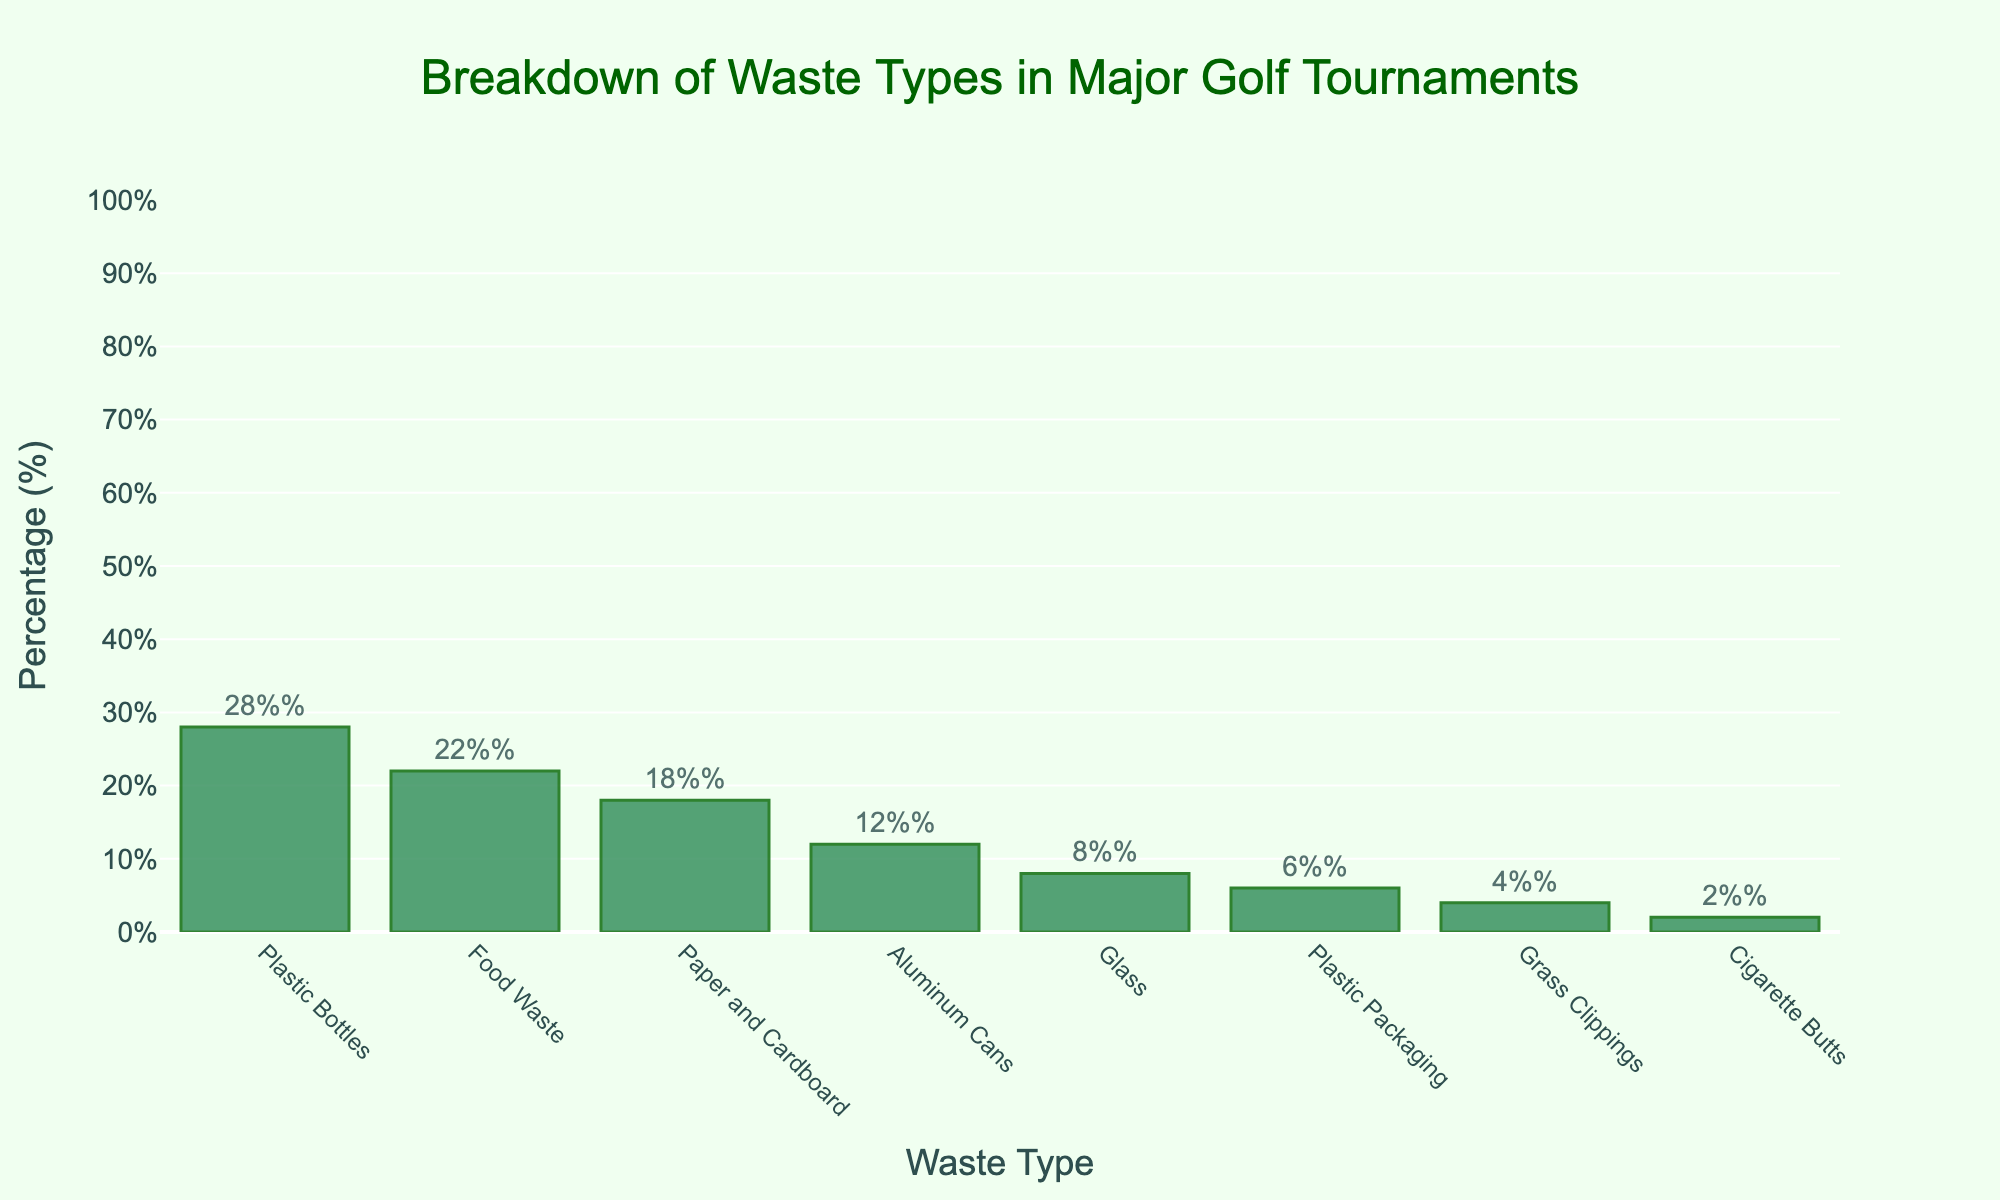What is the title of the histogram? The title can be found at the top of the histogram. It reads, "Breakdown of Waste Types in Major Golf Tournaments."
Answer: Breakdown of Waste Types in Major Golf Tournaments Which waste type has the highest percentage? The tallest bar in the histogram represents the waste type with the highest percentage. The "Plastic Bottles" bar is the tallest, indicating it has the highest percentage.
Answer: Plastic Bottles What are the percentage values for "Food Waste" and "Paper and Cardboard"? Look for the bars labeled "Food Waste" and "Paper and Cardboard" and read the percentages displayed on top of them. "Food Waste" is 22%, and "Paper and Cardboard" is 18%.
Answer: Food Waste: 22%, Paper and Cardboard: 18% How much more waste is generated from "Plastic Bottles" than "Aluminum Cans"? Identify the bars for "Plastic Bottles" and "Aluminum Cans". Subtract the percentage of "Aluminum Cans" (12%) from "Plastic Bottles" (28%). 28% - 12% = 16%.
Answer: 16% What is the combined percentage of "Plastic Bottles" and "Food Waste"? Add the percentages of "Plastic Bottles" (28%) and "Food Waste" (22%). 28% + 22% = 50%.
Answer: 50% Which waste types have a percentage below 10%? Identify the bars with percentages below the 10% mark. These are "Glass" (8%), "Plastic Packaging" (6%), "Grass Clippings" (4%), and "Cigarette Butts" (2%).
Answer: Glass, Plastic Packaging, Grass Clippings, and Cigarette Butts What is the total percentage of waste covered by "Glass", "Plastic Packaging", and "Grass Clippings"? Add the percentages of "Glass" (8%), "Plastic Packaging" (6%), and "Grass Clippings" (4%). 8% + 6% + 4% = 18%.
Answer: 18% How many waste types have a percentage value of 15% or higher? Identify bars with percentages 15% or higher. They are "Plastic Bottles" (28%), "Food Waste" (22%), and "Paper and Cardboard" (18%). Count these. There are 3.
Answer: 3 Which waste type has the smallest percentage, and what is its value? Locate the shortest bar in the histogram, which represents the smallest percentage. The "Cigarette Butts" bar is the shortest, showing the smallest percentage. Read its value, which is 2%.
Answer: Cigarette Butts; 2% What is the difference between the percentage of "Paper and Cardboard" and "Grass Clippings"? Identify the bars for "Paper and Cardboard" and "Grass Clippings". Subtract the percentage of "Grass Clippings" (4%) from "Paper and Cardboard" (18%). 18% - 4% = 14%.
Answer: 14% 